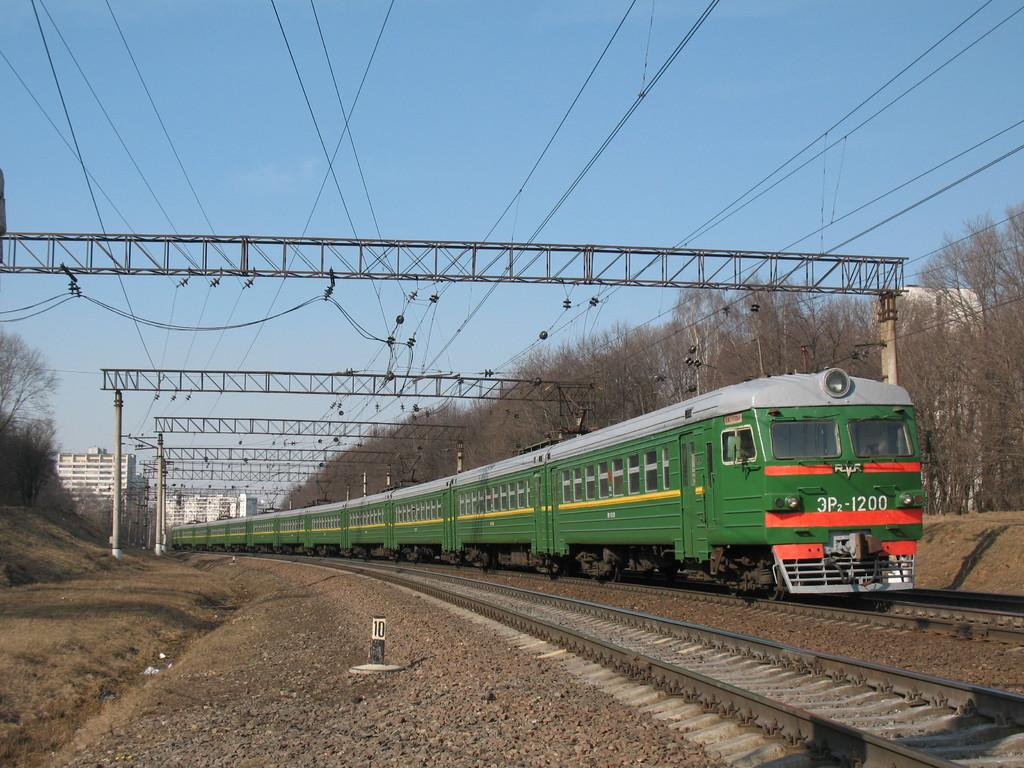What is the main subject of the image? The main subject of the image is a train. Where is the train located in the image? The train is on a railway track. What can be seen in the background of the image? In the background of the image, there are metal rods and wires, buildings, trees, and the sky. What color is the vest worn by the oatmeal in the image? There is no vest or oatmeal present in the image; it features a train on a railway track with a background of metal rods and wires, buildings, trees, and the sky. 